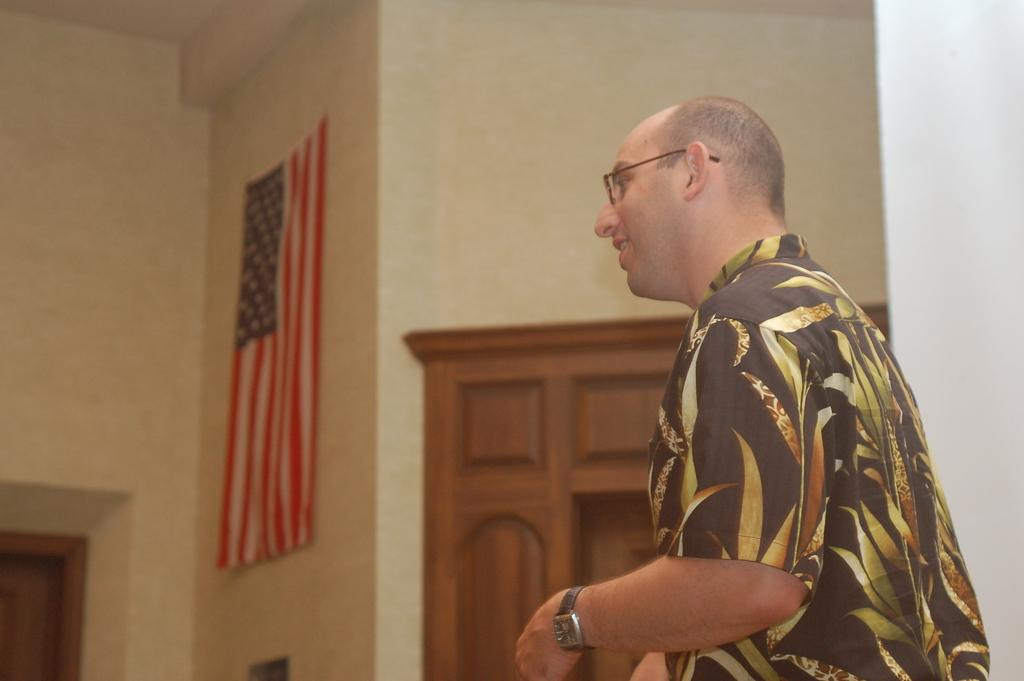What is the main subject of the image? There is a person standing in the center of the image. Can you describe the person's appearance? The person is wearing glasses. What can be seen in the background of the image? There is a flag, a wall, and a door in the background of the image. What type of bead is being exchanged between the person and the flag in the image? There is no bead or exchange taking place in the image; the person is simply standing in front of a flag and a wall. 